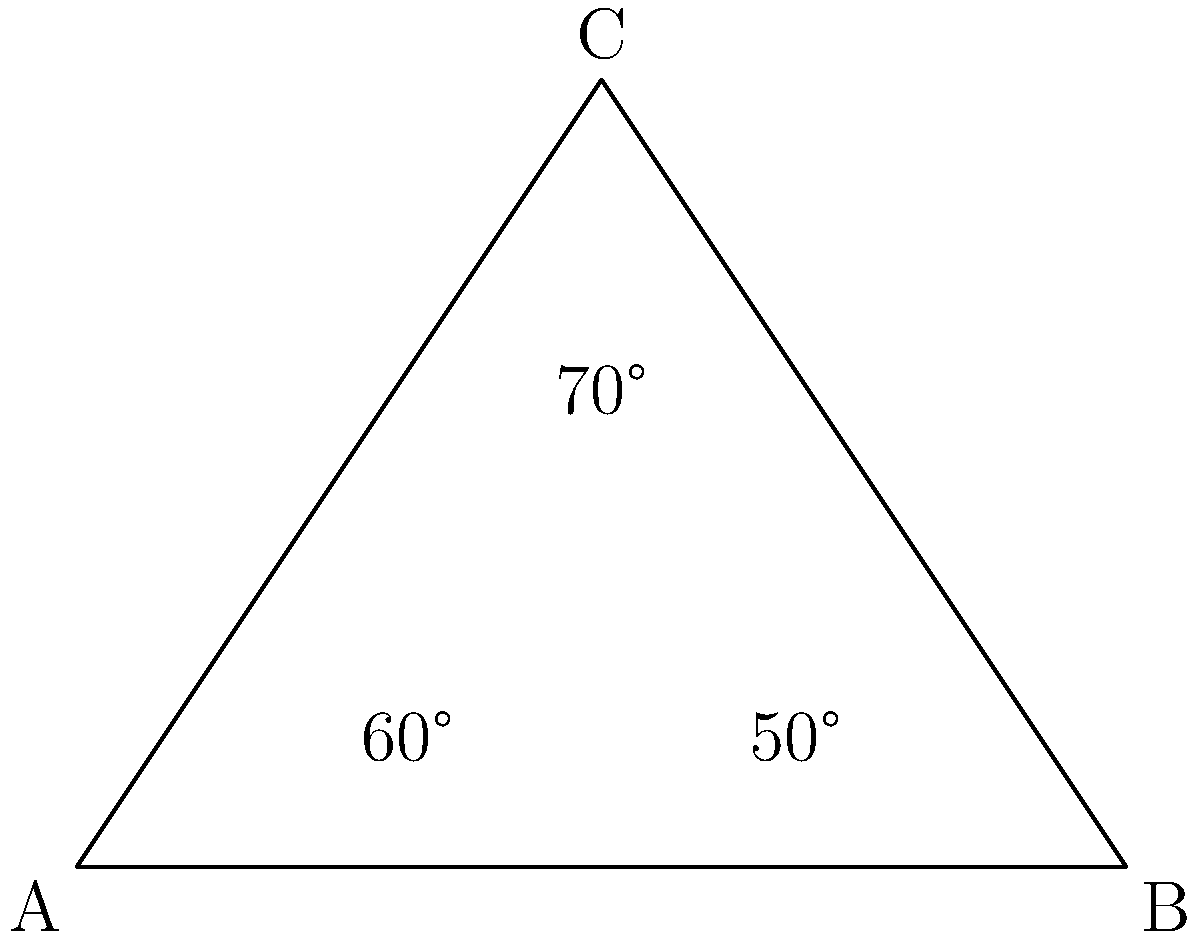In your latest music video, you're collaborating with a team of dancers for a groundbreaking choreography. The formation creates a triangle, with you at the apex and two dancers at the base. If the angles at the base are 60° and 50°, what's the angle at the apex where you're standing? Let's break this down step-by-step:

1) First, recall that the sum of angles in a triangle is always 180°.

2) We're given two angles in the triangle:
   - One base angle is 60°
   - The other base angle is 50°

3) Let's call the apex angle $x$. We can set up an equation:
   $$ 60° + 50° + x = 180° $$

4) Simplify the left side of the equation:
   $$ 110° + x = 180° $$

5) Subtract 110° from both sides:
   $$ x = 180° - 110° $$

6) Solve for $x$:
   $$ x = 70° $$

Therefore, the angle at the apex where you're standing is 70°.
Answer: 70° 